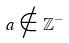<formula> <loc_0><loc_0><loc_500><loc_500>a \notin \mathbb { Z } ^ { - }</formula> 